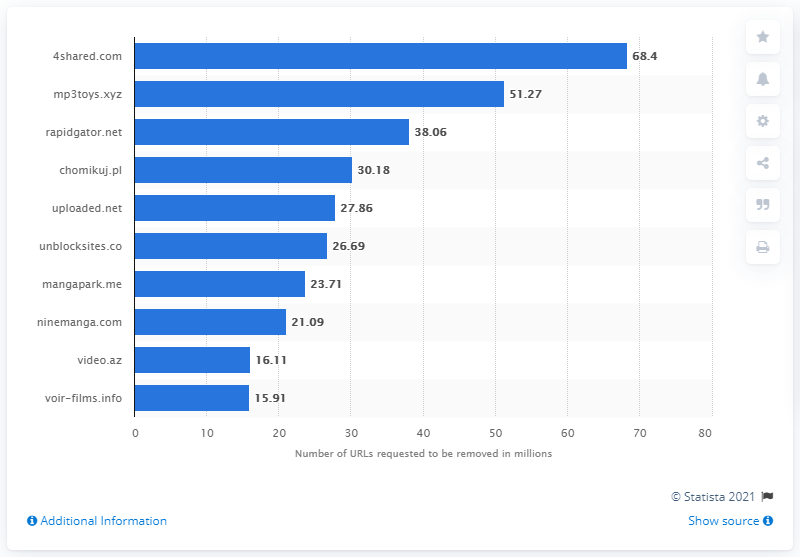Draw attention to some important aspects in this diagram. It is true that the total number of URLs requested to be removed from mp3toys.xyz and rapidgattor.net exceeds the number of URLs requested to be removed from 4shared.com. As of February 2021, Google had received 68.4 requests to remove URLs from its search results. As of February 2021, 4shared.com was the most targeted website. There were approximately 15.91 million URLs requested to be removed. 